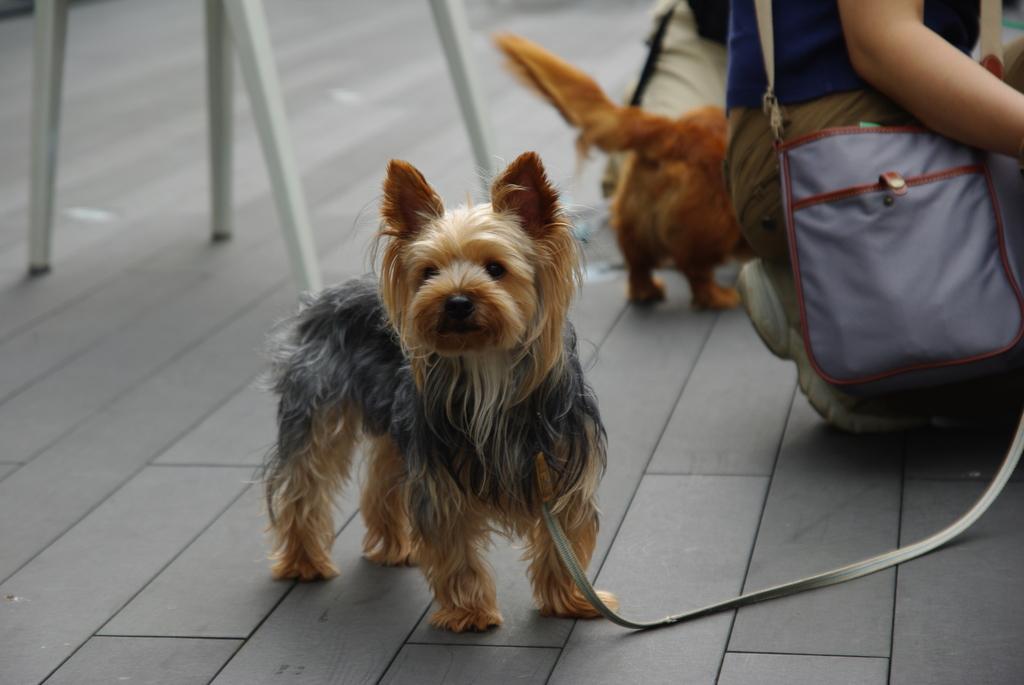In one or two sentences, can you explain what this image depicts? In this image in the center there is one dog, and in the background there are two persons and one dog. At the bottom there is a floor, and on the top of the left corner there are some sticks. 